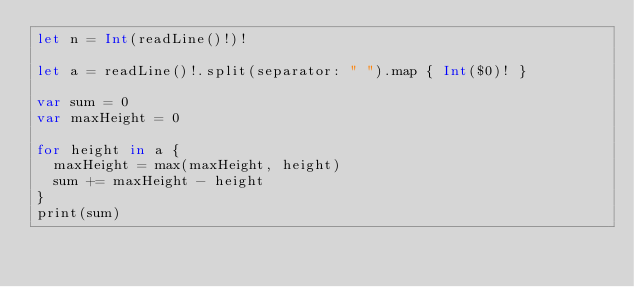<code> <loc_0><loc_0><loc_500><loc_500><_Swift_>let n = Int(readLine()!)!

let a = readLine()!.split(separator: " ").map { Int($0)! }

var sum = 0
var maxHeight = 0

for height in a {
  maxHeight = max(maxHeight, height)
  sum += maxHeight - height
}
print(sum)</code> 